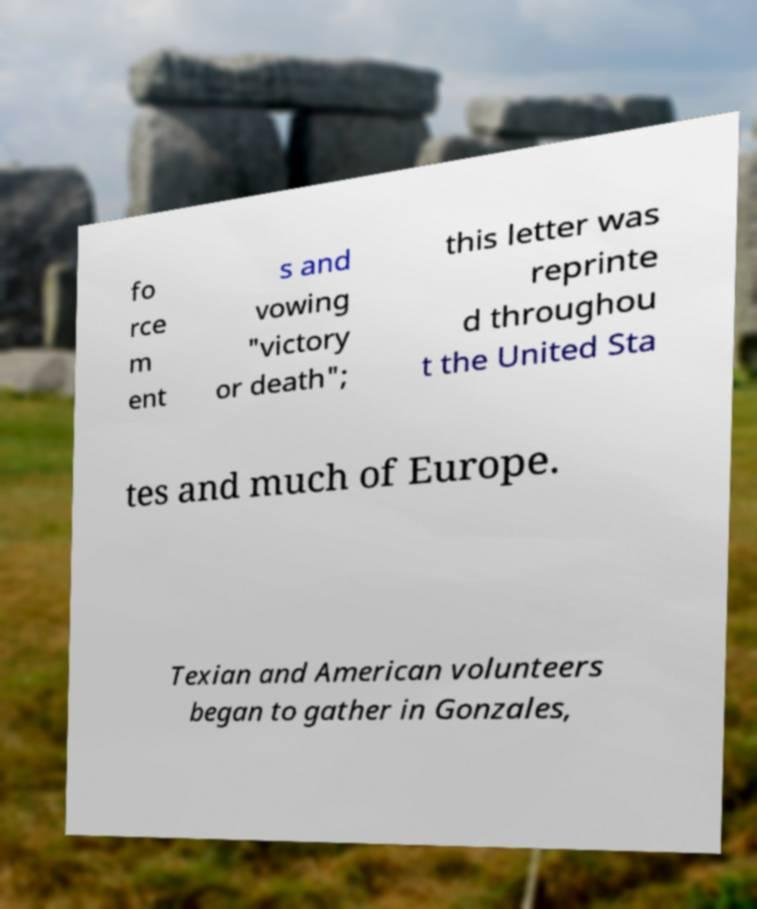For documentation purposes, I need the text within this image transcribed. Could you provide that? fo rce m ent s and vowing "victory or death"; this letter was reprinte d throughou t the United Sta tes and much of Europe. Texian and American volunteers began to gather in Gonzales, 